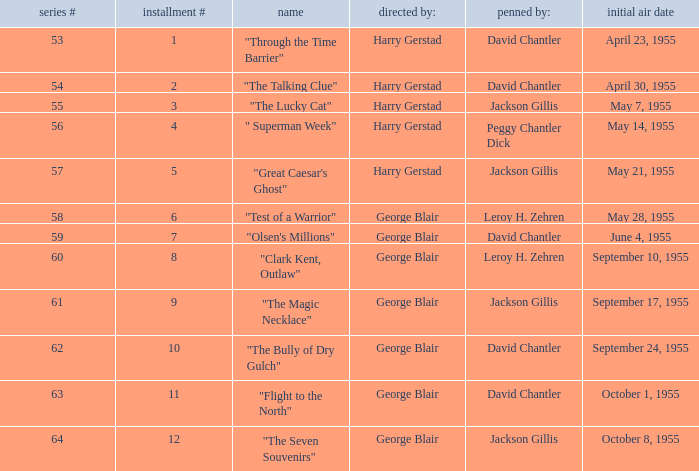What is the lowest number of series? 53.0. 